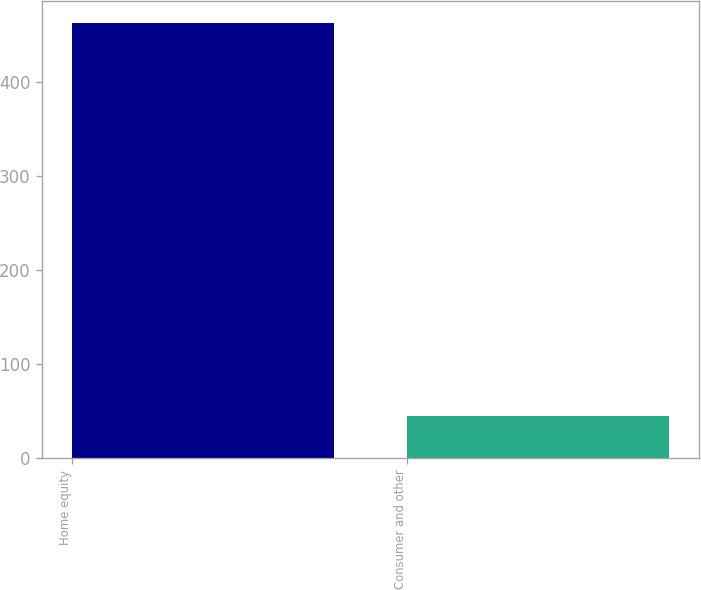Convert chart. <chart><loc_0><loc_0><loc_500><loc_500><bar_chart><fcel>Home equity<fcel>Consumer and other<nl><fcel>463.3<fcel>45.3<nl></chart> 